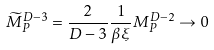<formula> <loc_0><loc_0><loc_500><loc_500>\widetilde { M } _ { P } ^ { D - 3 } = \frac { 2 } { D - 3 } \frac { 1 } { \beta \xi } M _ { P } ^ { D - 2 } \rightarrow 0</formula> 